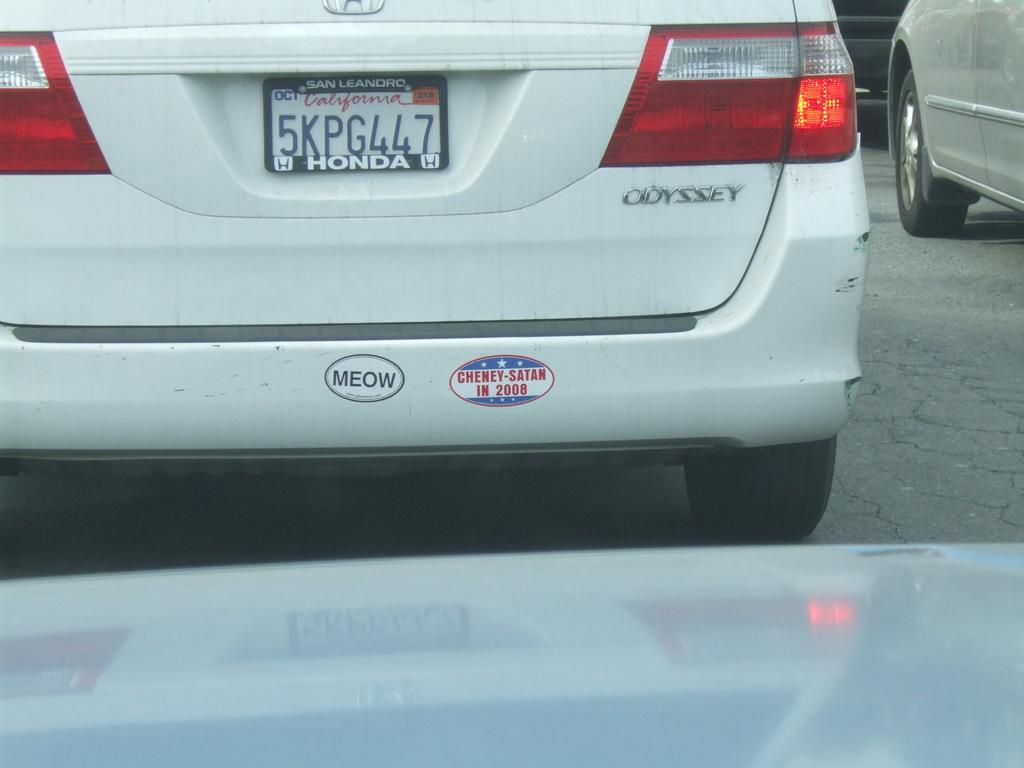What is happening on the road in the image? There are vehicles on the road in the image. Can you describe one of the vehicles in the image? There is a white color car in the image. What feature of the car can be seen in the image? The car has a number plate. What type of silk is draped over the car in the image? There is no silk present in the image; it only shows vehicles on the road, including a white color car with a number plate. 